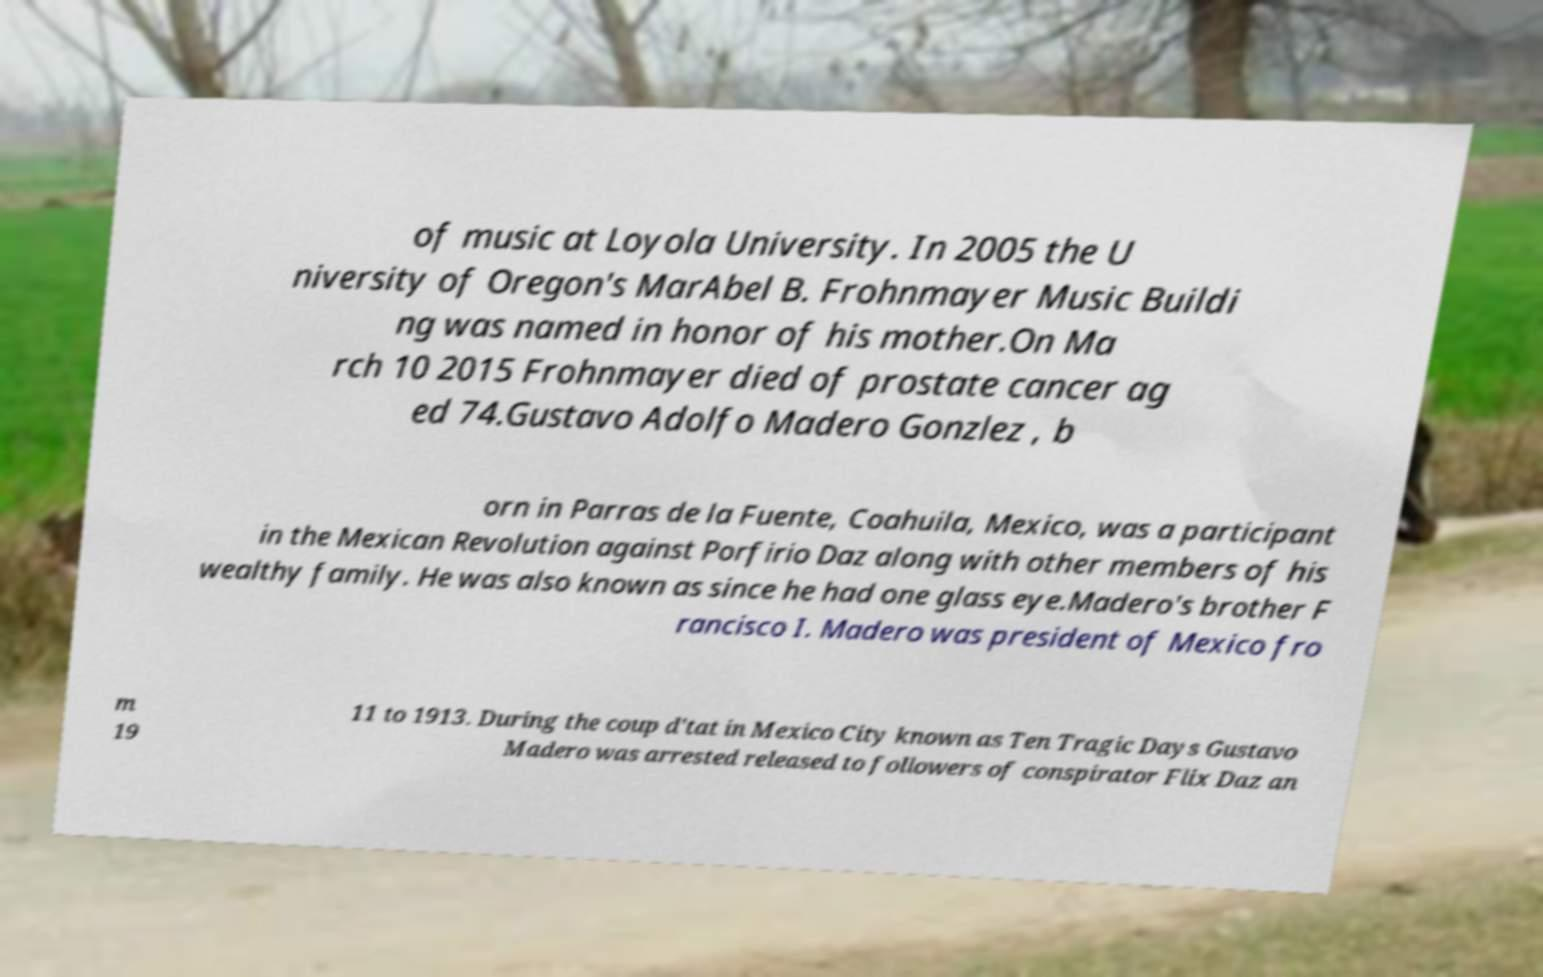Could you assist in decoding the text presented in this image and type it out clearly? of music at Loyola University. In 2005 the U niversity of Oregon's MarAbel B. Frohnmayer Music Buildi ng was named in honor of his mother.On Ma rch 10 2015 Frohnmayer died of prostate cancer ag ed 74.Gustavo Adolfo Madero Gonzlez , b orn in Parras de la Fuente, Coahuila, Mexico, was a participant in the Mexican Revolution against Porfirio Daz along with other members of his wealthy family. He was also known as since he had one glass eye.Madero's brother F rancisco I. Madero was president of Mexico fro m 19 11 to 1913. During the coup d'tat in Mexico City known as Ten Tragic Days Gustavo Madero was arrested released to followers of conspirator Flix Daz an 